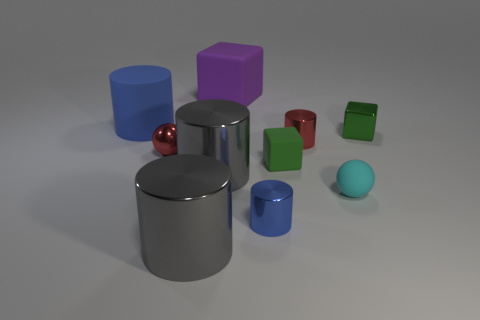Do these items have a real-world function, or are they purely ornamental? Although these items are rendered and therefore don't have a physical presence, in the real-world similar objects could be functional as children's blocks, design elements, or as part of a larger artwork. Their function would depend on the context in which they are used. Could we determine the size of these objects? Without a reference object of known size in the image, it's challenging to determine the exact size of these objects. However, if we assume they are scaled similarly to common everyday objects, they could range from a few centimeters to several inches in diameter. 